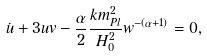Convert formula to latex. <formula><loc_0><loc_0><loc_500><loc_500>\dot { u } + 3 u v - \frac { \alpha } { 2 } \frac { k m _ { P l } ^ { 2 } } { H _ { 0 } ^ { 2 } } w ^ { - ( \alpha + 1 ) } = 0 ,</formula> 